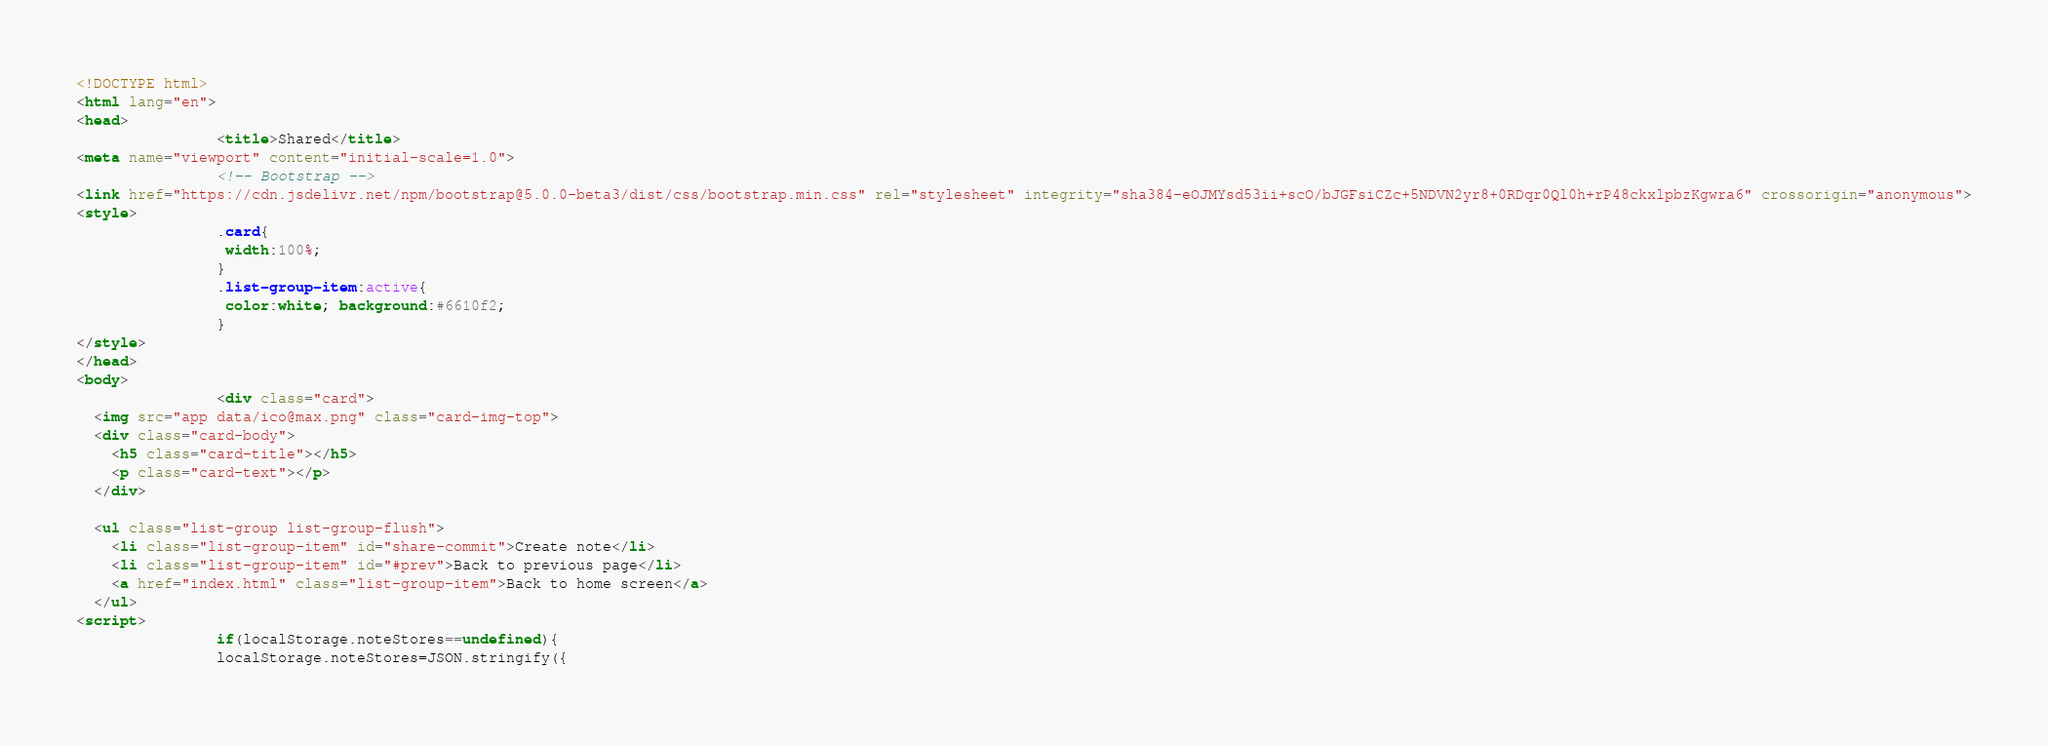<code> <loc_0><loc_0><loc_500><loc_500><_HTML_><!DOCTYPE html>
<html lang="en">
<head>
				<title>Shared</title>
<meta name="viewport" content="initial-scale=1.0">
				<!-- Bootstrap -->
<link href="https://cdn.jsdelivr.net/npm/bootstrap@5.0.0-beta3/dist/css/bootstrap.min.css" rel="stylesheet" integrity="sha384-eOJMYsd53ii+scO/bJGFsiCZc+5NDVN2yr8+0RDqr0Ql0h+rP48ckxlpbzKgwra6" crossorigin="anonymous">
<style>
				.card{
				 width:100%;
				}
				.list-group-item:active{
				 color:white; background:#6610f2;
				}
</style>
</head>
<body>
				<div class="card">
  <img src="app data/ico@max.png" class="card-img-top">
  <div class="card-body">
    <h5 class="card-title"></h5>
    <p class="card-text"></p>
  </div>
  
  <ul class="list-group list-group-flush">
    <li class="list-group-item" id="share-commit">Create note</li>
    <li class="list-group-item" id="#prev">Back to previous page</li>
    <a href="index.html" class="list-group-item">Back to home screen</a>
  </ul>
<script>
				if(localStorage.noteStores==undefined){
  				localStorage.noteStores=JSON.stringify({</code> 